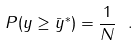<formula> <loc_0><loc_0><loc_500><loc_500>P ( y \geq \bar { y } ^ { * } ) = \frac { 1 } { N } \ .</formula> 